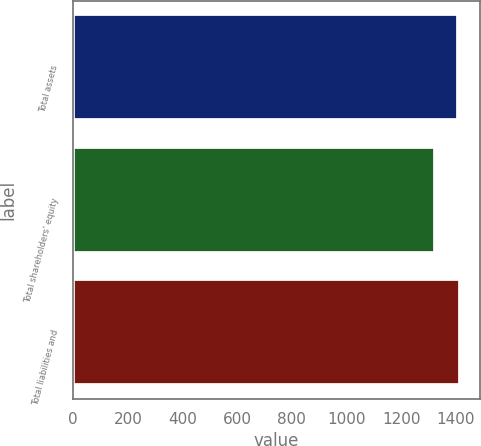Convert chart to OTSL. <chart><loc_0><loc_0><loc_500><loc_500><bar_chart><fcel>Total assets<fcel>Total shareholders' equity<fcel>Total liabilities and<nl><fcel>1408<fcel>1323<fcel>1416.5<nl></chart> 